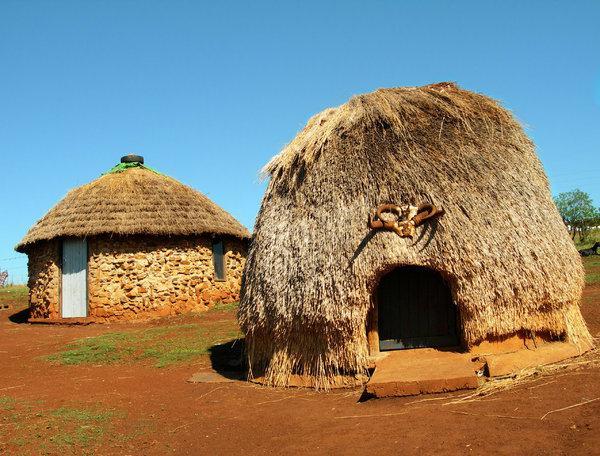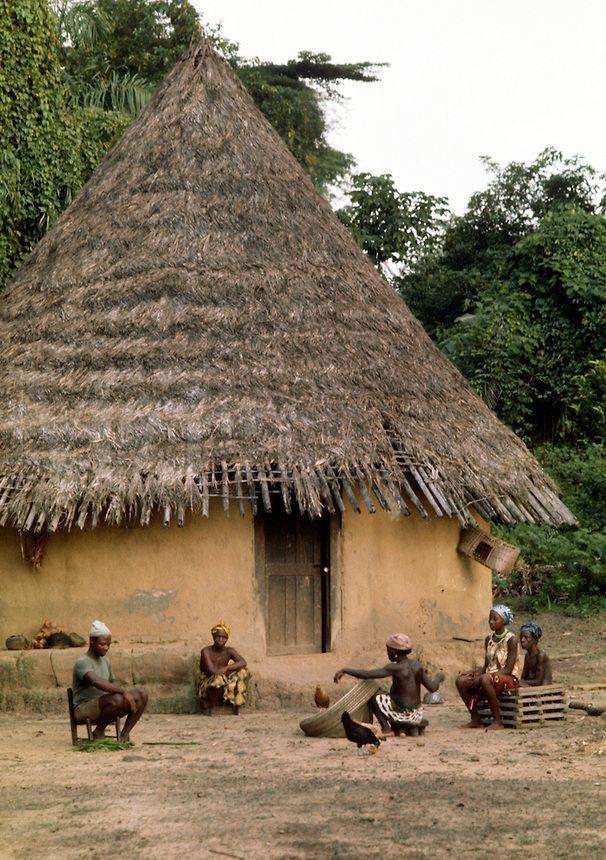The first image is the image on the left, the second image is the image on the right. For the images displayed, is the sentence "None of the shelters have a door." factually correct? Answer yes or no. No. The first image is the image on the left, the second image is the image on the right. Given the left and right images, does the statement "At least one of the images contains a simple structure with a wide door opening and thick thatching that covers the whole structure." hold true? Answer yes or no. Yes. 